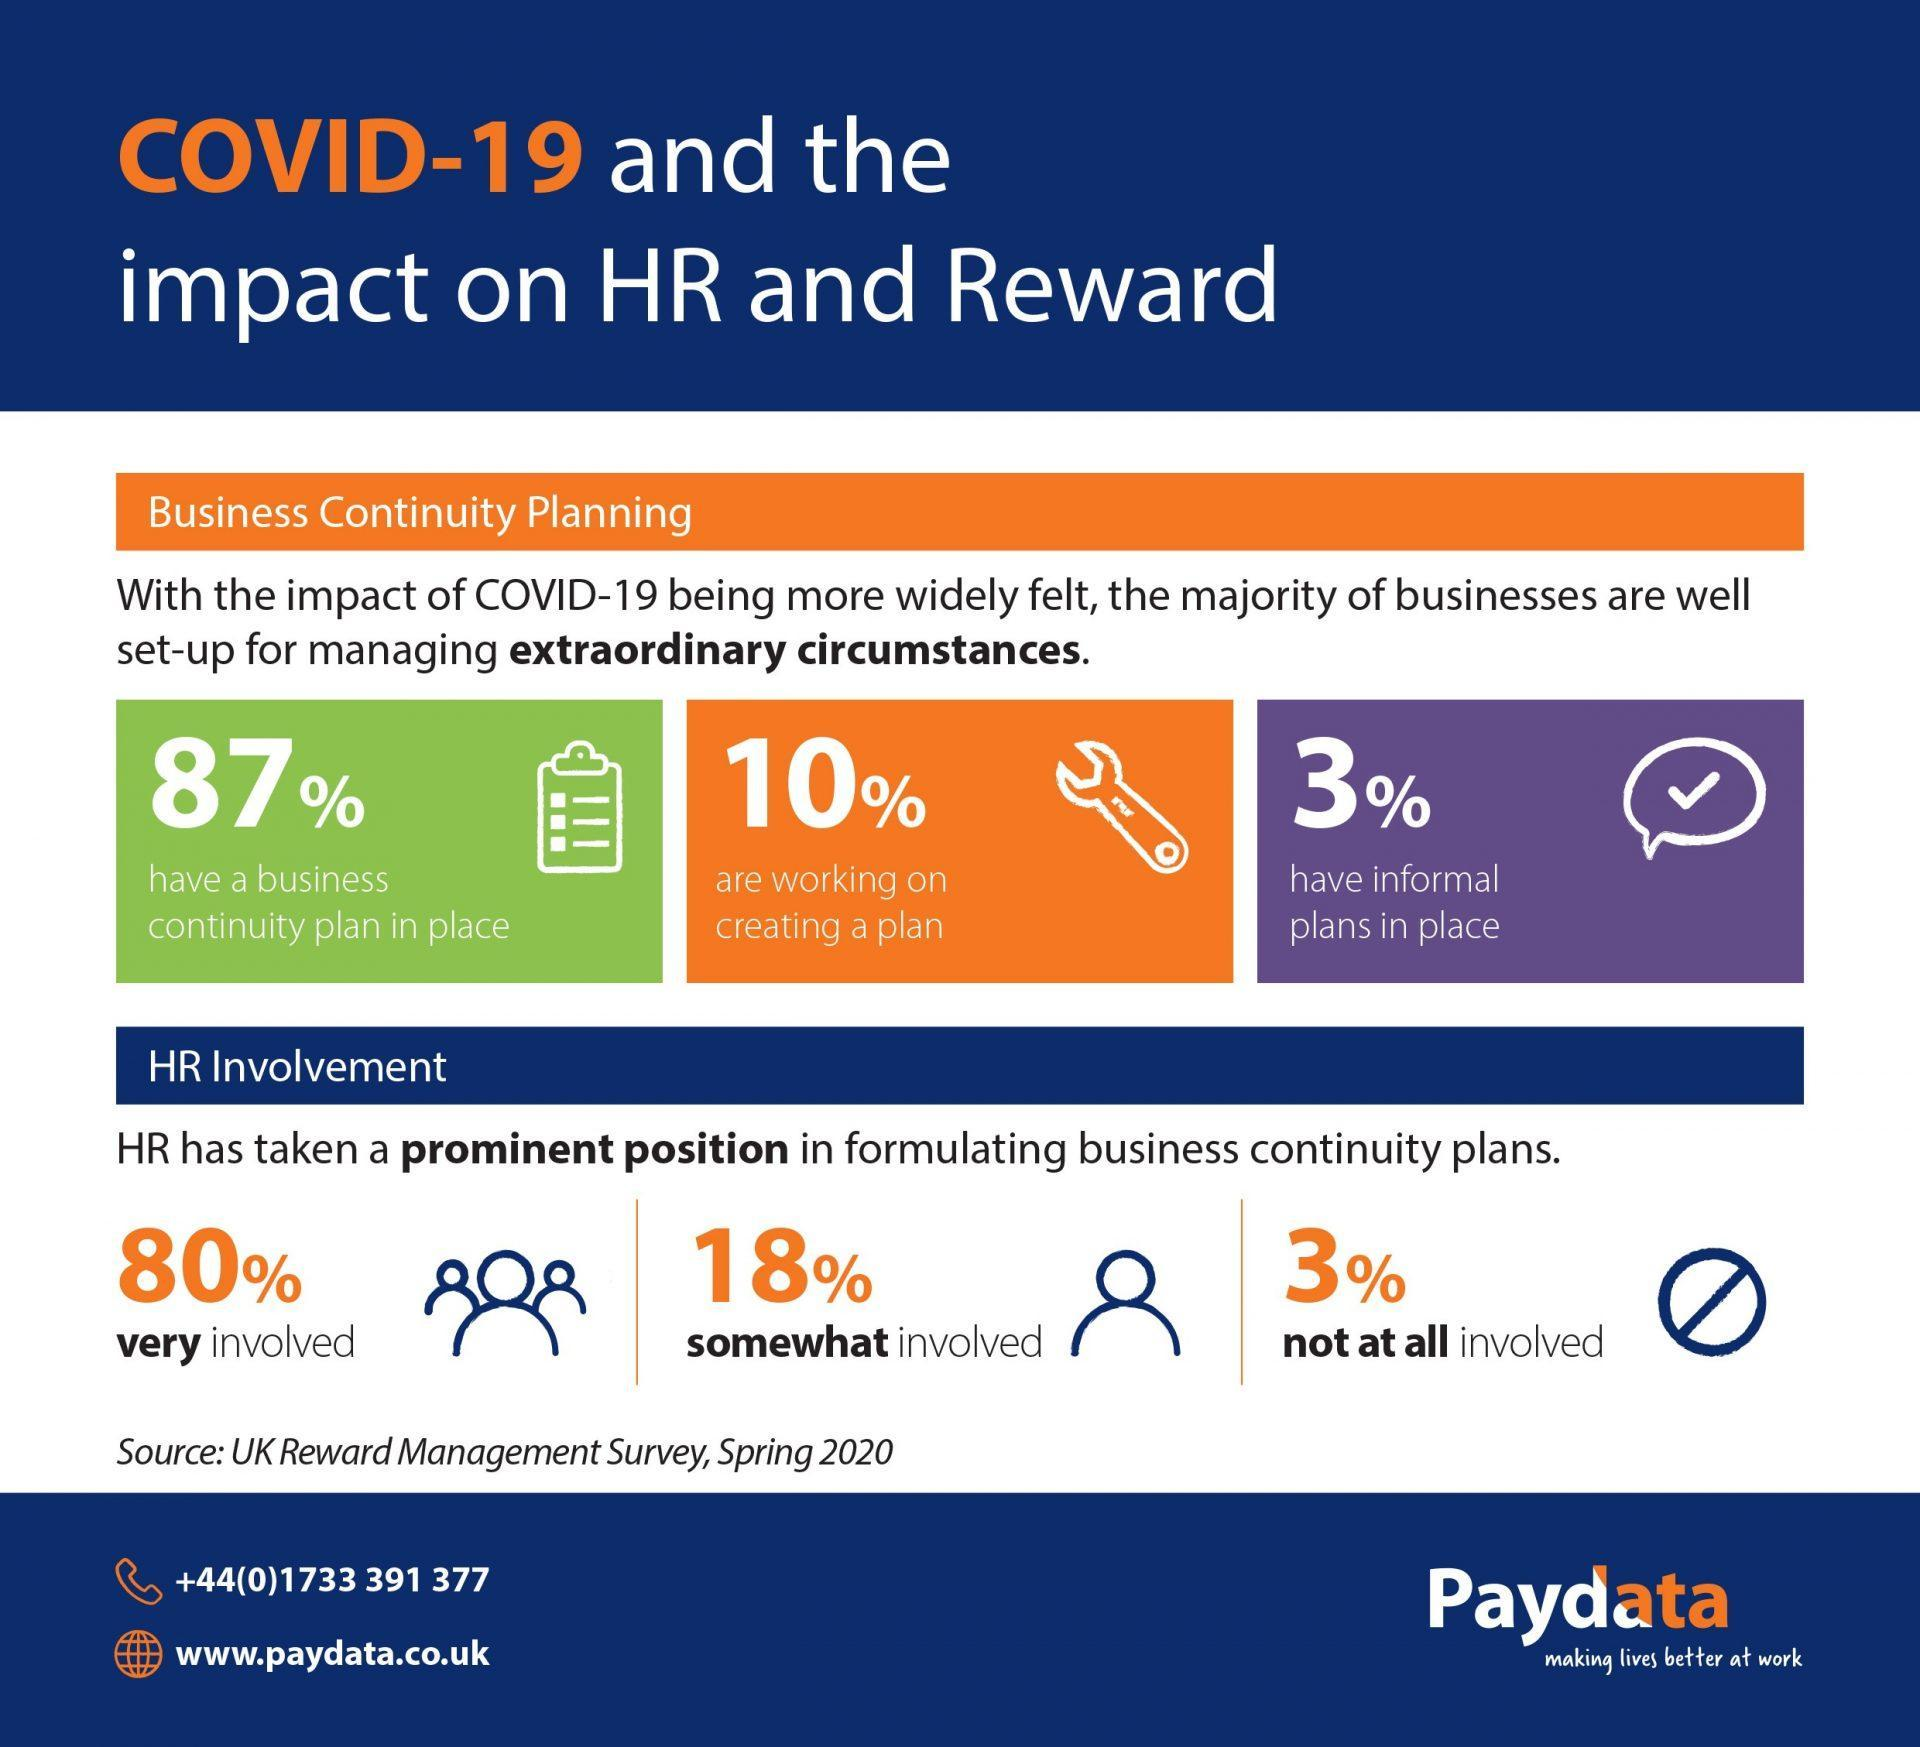What percentage of businesses do not have continuity plan in place?
Answer the question with a short phrase. 13% What percentage of businesses are working on creating a plan? 10% What percentage of HR are very much involved in formulating business continuity pans? 80% What percentage of HR are not at all involved in formulating business continuity pans? 3% What percentage of businesses have informal plans in place? 3% 